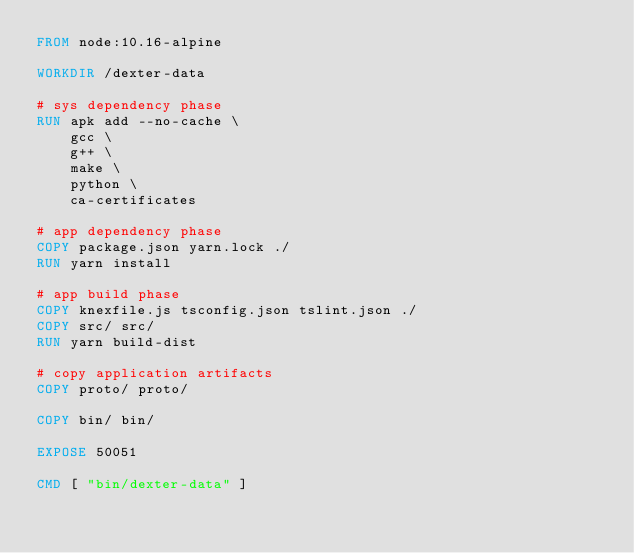<code> <loc_0><loc_0><loc_500><loc_500><_Dockerfile_>FROM node:10.16-alpine

WORKDIR /dexter-data

# sys dependency phase
RUN apk add --no-cache \
    gcc \
    g++ \
    make \
    python \
    ca-certificates

# app dependency phase
COPY package.json yarn.lock ./
RUN yarn install

# app build phase
COPY knexfile.js tsconfig.json tslint.json ./
COPY src/ src/
RUN yarn build-dist

# copy application artifacts
COPY proto/ proto/

COPY bin/ bin/

EXPOSE 50051

CMD [ "bin/dexter-data" ]
</code> 